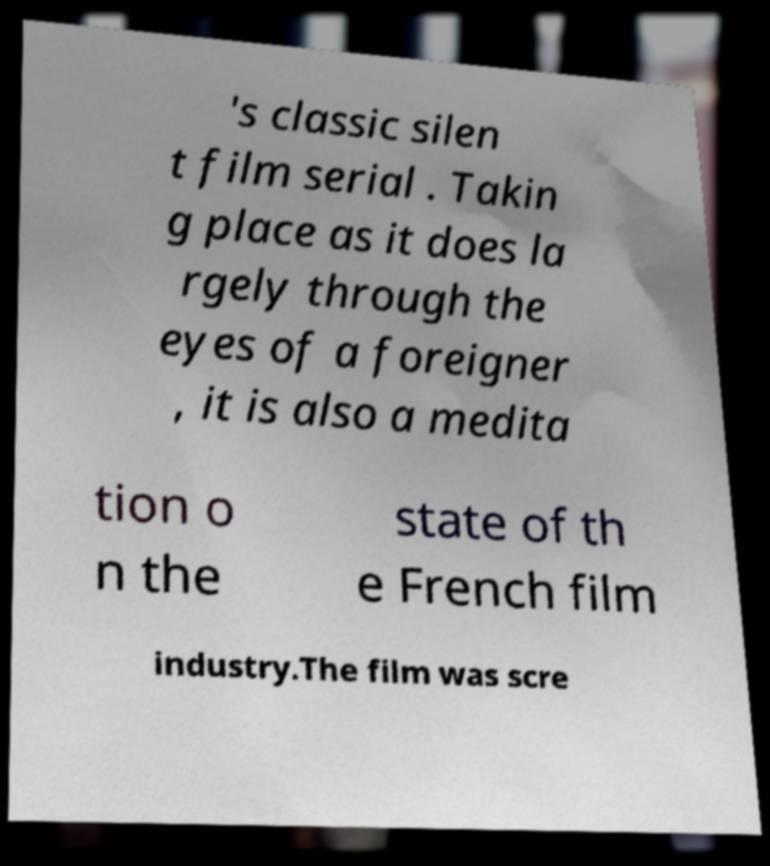Could you extract and type out the text from this image? 's classic silen t film serial . Takin g place as it does la rgely through the eyes of a foreigner , it is also a medita tion o n the state of th e French film industry.The film was scre 